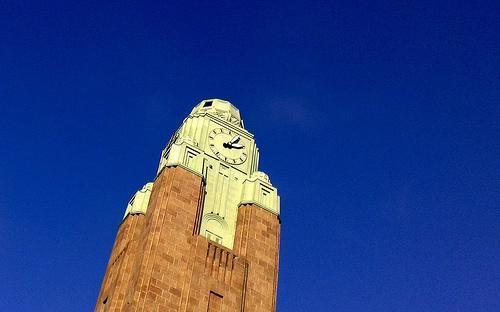How many hands are on the clock?
Give a very brief answer. 2. 